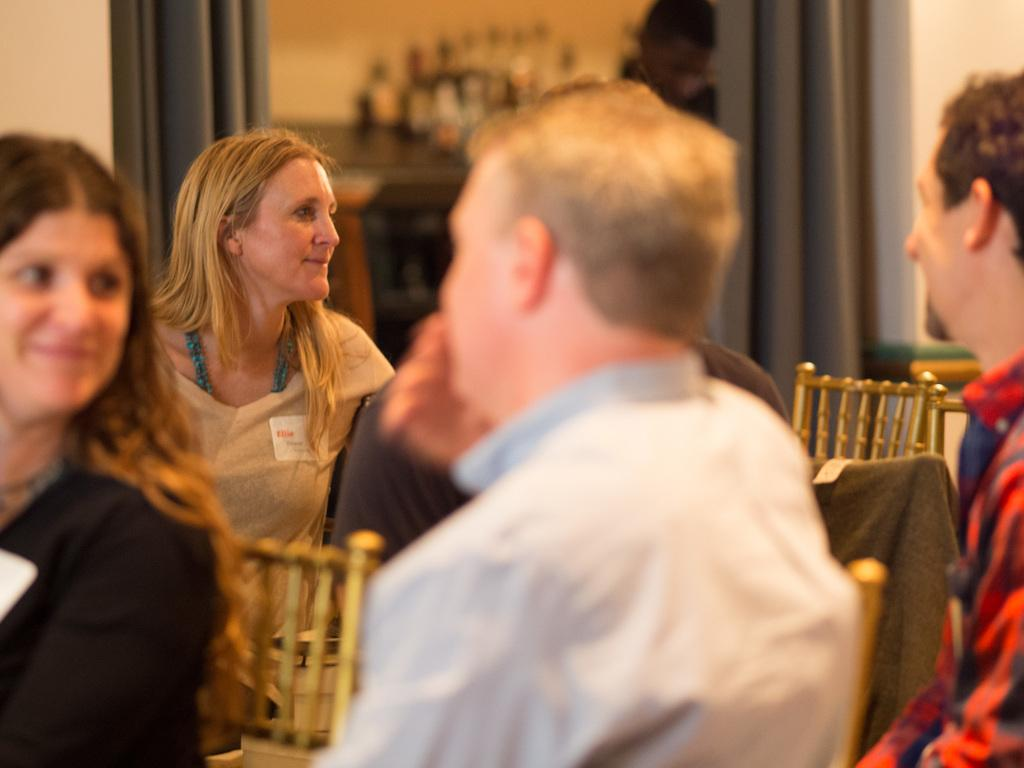What are the people in the image doing? The persons in the image are sitting on chairs. What can be seen in the background of the image? There are curtains visible in the background of the image. What type of zebra can be seen walking along the curve in the image? There is no zebra present in the image, and no curve is visible. 